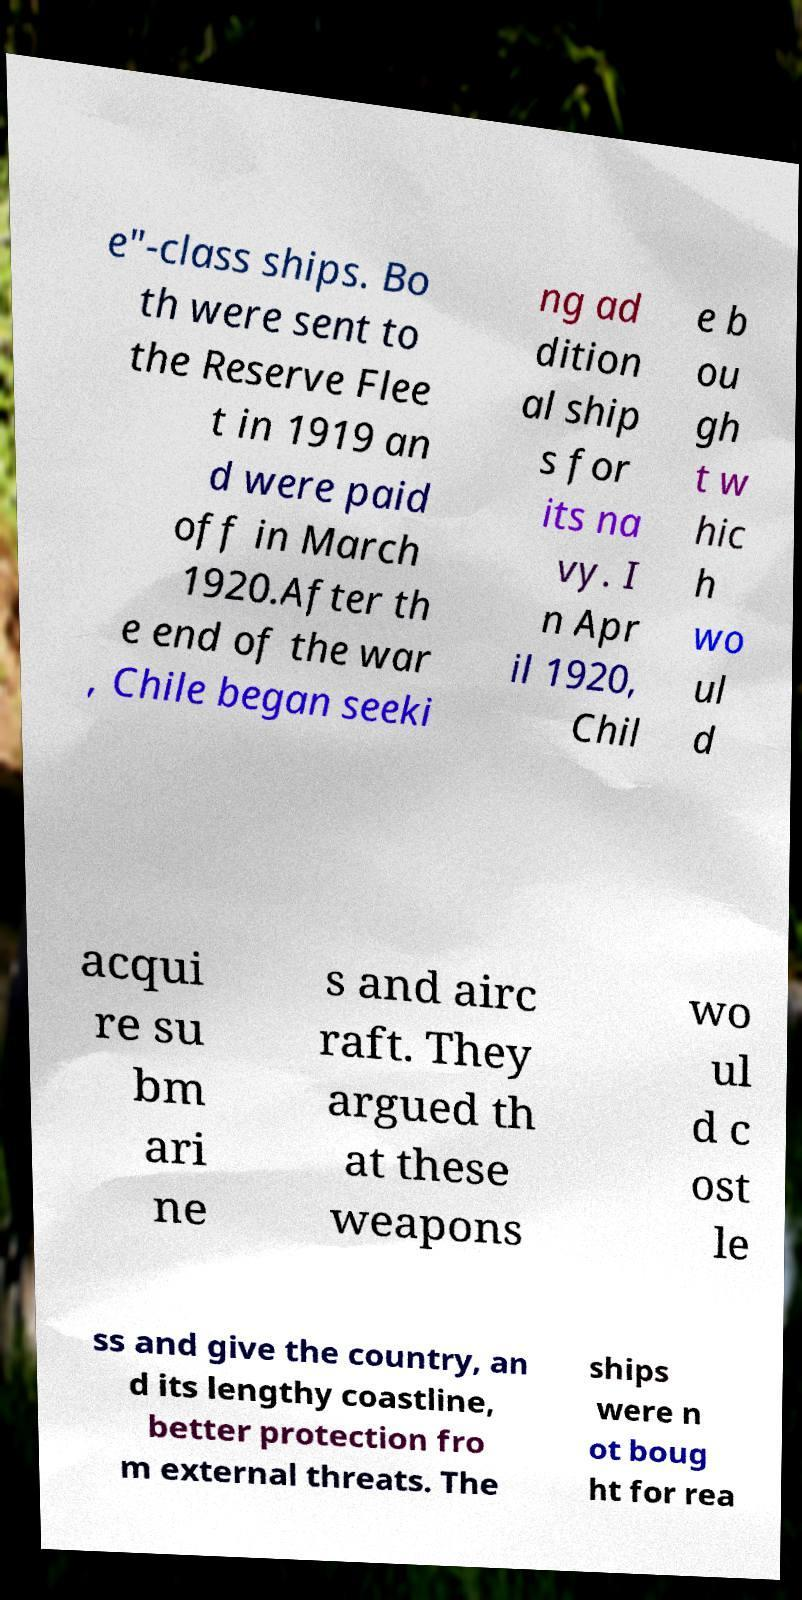Please identify and transcribe the text found in this image. e"-class ships. Bo th were sent to the Reserve Flee t in 1919 an d were paid off in March 1920.After th e end of the war , Chile began seeki ng ad dition al ship s for its na vy. I n Apr il 1920, Chil e b ou gh t w hic h wo ul d acqui re su bm ari ne s and airc raft. They argued th at these weapons wo ul d c ost le ss and give the country, an d its lengthy coastline, better protection fro m external threats. The ships were n ot boug ht for rea 